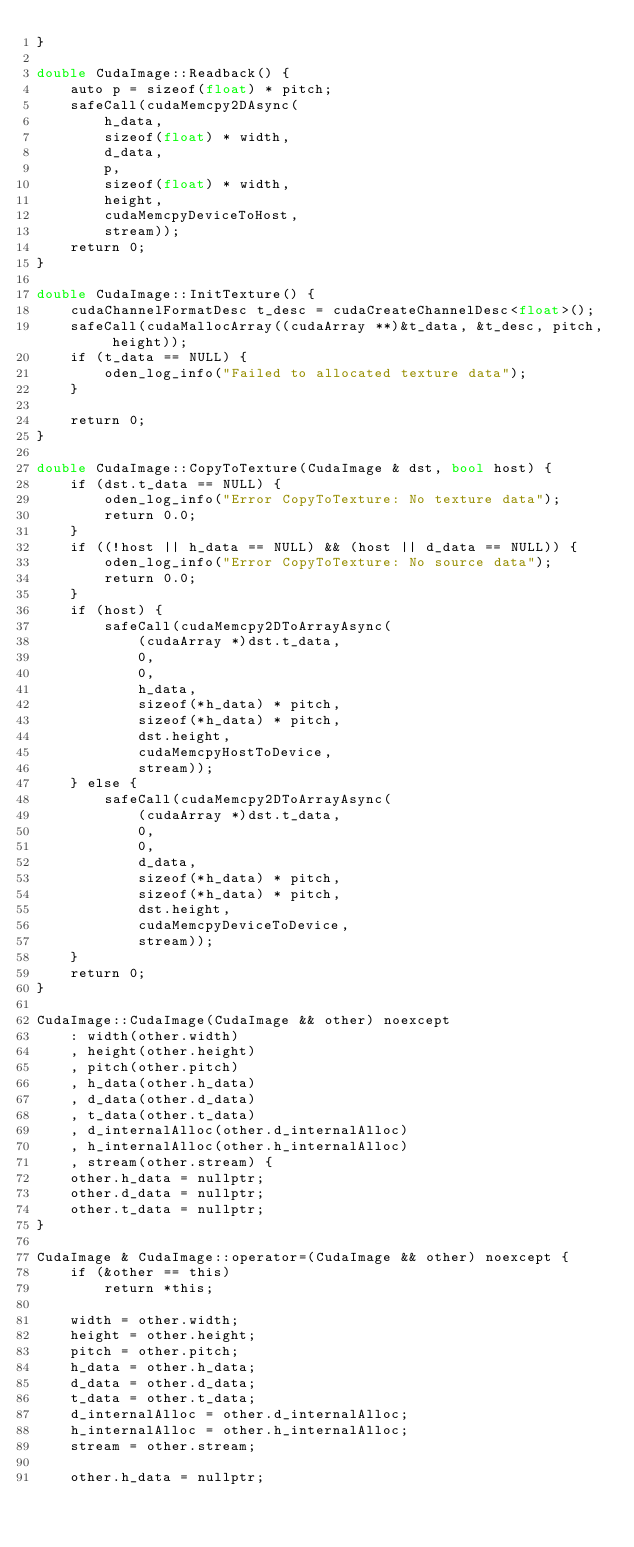Convert code to text. <code><loc_0><loc_0><loc_500><loc_500><_Cuda_>}

double CudaImage::Readback() {
    auto p = sizeof(float) * pitch;
    safeCall(cudaMemcpy2DAsync(
        h_data,
        sizeof(float) * width,
        d_data,
        p,
        sizeof(float) * width,
        height,
        cudaMemcpyDeviceToHost,
        stream));
    return 0;
}

double CudaImage::InitTexture() {
    cudaChannelFormatDesc t_desc = cudaCreateChannelDesc<float>();
    safeCall(cudaMallocArray((cudaArray **)&t_data, &t_desc, pitch, height));
    if (t_data == NULL) {
        oden_log_info("Failed to allocated texture data");
    }

    return 0;
}

double CudaImage::CopyToTexture(CudaImage & dst, bool host) {
    if (dst.t_data == NULL) {
        oden_log_info("Error CopyToTexture: No texture data");
        return 0.0;
    }
    if ((!host || h_data == NULL) && (host || d_data == NULL)) {
        oden_log_info("Error CopyToTexture: No source data");
        return 0.0;
    }
    if (host) {
        safeCall(cudaMemcpy2DToArrayAsync(
            (cudaArray *)dst.t_data,
            0,
            0,
            h_data,
            sizeof(*h_data) * pitch,
            sizeof(*h_data) * pitch,
            dst.height,
            cudaMemcpyHostToDevice,
            stream));
    } else {
        safeCall(cudaMemcpy2DToArrayAsync(
            (cudaArray *)dst.t_data,
            0,
            0,
            d_data,
            sizeof(*h_data) * pitch,
            sizeof(*h_data) * pitch,
            dst.height,
            cudaMemcpyDeviceToDevice,
            stream));
    }
    return 0;
}

CudaImage::CudaImage(CudaImage && other) noexcept
    : width(other.width)
    , height(other.height)
    , pitch(other.pitch)
    , h_data(other.h_data)
    , d_data(other.d_data)
    , t_data(other.t_data)
    , d_internalAlloc(other.d_internalAlloc)
    , h_internalAlloc(other.h_internalAlloc)
    , stream(other.stream) {
    other.h_data = nullptr;
    other.d_data = nullptr;
    other.t_data = nullptr;
}

CudaImage & CudaImage::operator=(CudaImage && other) noexcept {
    if (&other == this)
        return *this;

    width = other.width;
    height = other.height;
    pitch = other.pitch;
    h_data = other.h_data;
    d_data = other.d_data;
    t_data = other.t_data;
    d_internalAlloc = other.d_internalAlloc;
    h_internalAlloc = other.h_internalAlloc;
    stream = other.stream;

    other.h_data = nullptr;</code> 